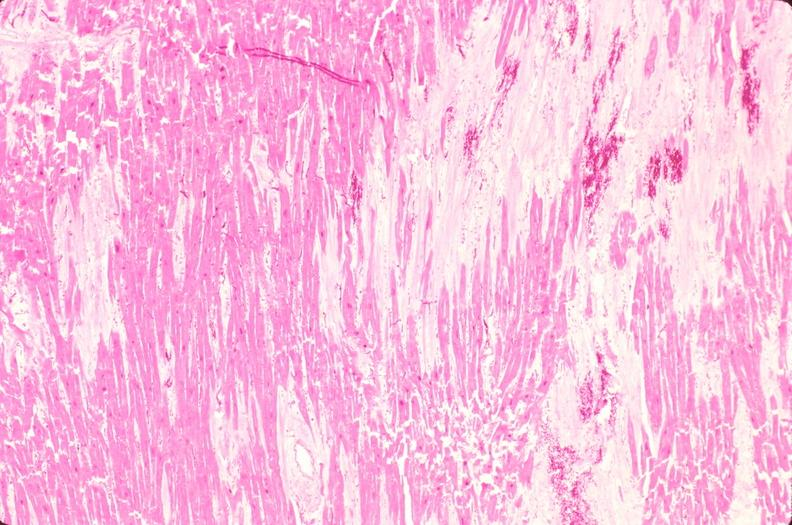what is present?
Answer the question using a single word or phrase. Cardiovascular 